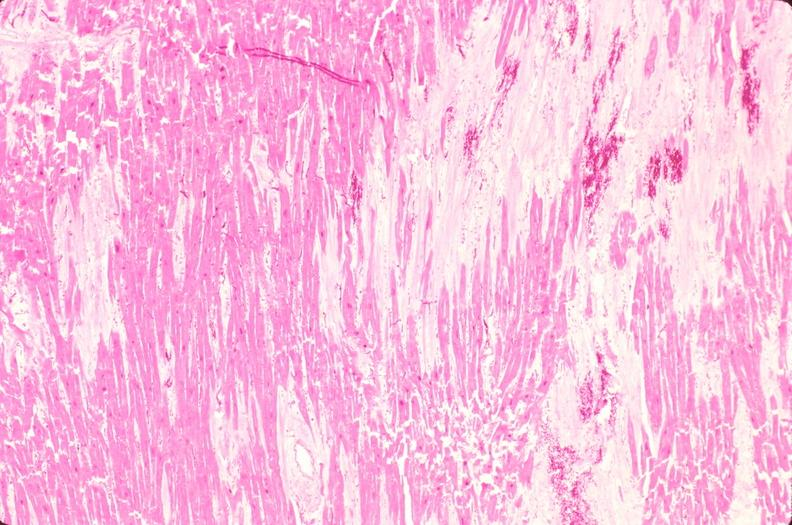what is present?
Answer the question using a single word or phrase. Cardiovascular 